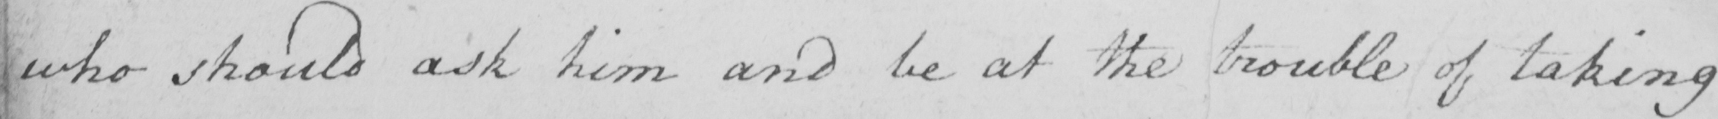Please provide the text content of this handwritten line. who should ask him and be at the trouble of taking 